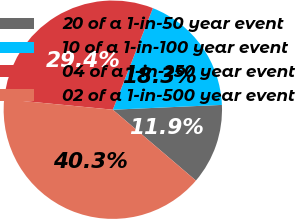<chart> <loc_0><loc_0><loc_500><loc_500><pie_chart><fcel>20 of a 1-in-50 year event<fcel>10 of a 1-in-100 year event<fcel>04 of a 1-in-250 year event<fcel>02 of a 1-in-500 year event<nl><fcel>11.94%<fcel>18.32%<fcel>29.44%<fcel>40.3%<nl></chart> 